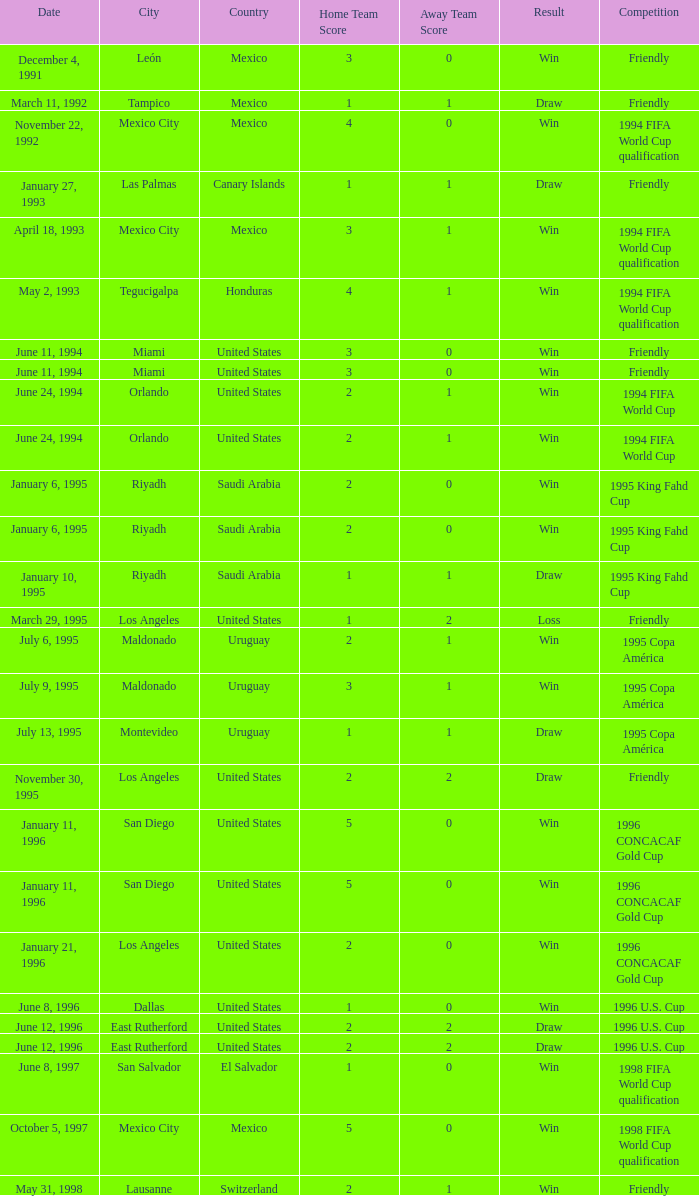What is Score, when Venue is Riyadh, Saudi Arabia, and when Result is "Win"? 2–0, 2–0. 